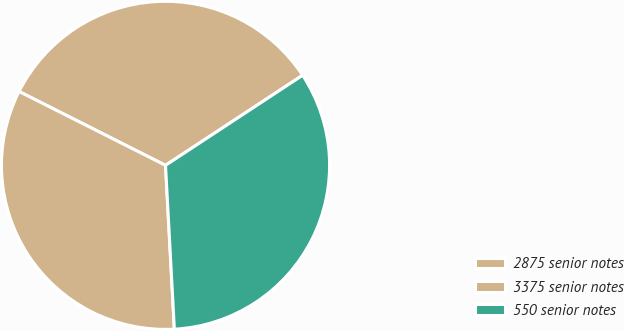Convert chart. <chart><loc_0><loc_0><loc_500><loc_500><pie_chart><fcel>2875 senior notes<fcel>3375 senior notes<fcel>550 senior notes<nl><fcel>33.31%<fcel>33.29%<fcel>33.39%<nl></chart> 